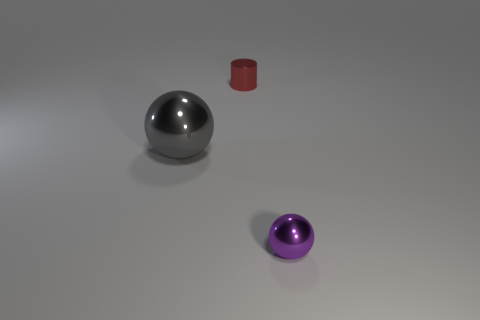What number of purple metal objects are the same size as the red metal thing?
Your answer should be very brief. 1. Is the number of tiny shiny things less than the number of small purple balls?
Provide a short and direct response. No. What shape is the small shiny thing on the left side of the shiny sphere in front of the gray ball?
Your response must be concise. Cylinder. There is a metal thing that is the same size as the cylinder; what shape is it?
Your response must be concise. Sphere. Is there a small green object that has the same shape as the large gray metal object?
Your answer should be very brief. No. What is the material of the red cylinder?
Ensure brevity in your answer.  Metal. There is a purple thing; are there any tiny purple balls to the right of it?
Provide a succinct answer. No. There is a ball behind the purple ball; what number of purple objects are on the right side of it?
Provide a succinct answer. 1. What is the material of the purple thing that is the same size as the red cylinder?
Your answer should be compact. Metal. What number of other things are there of the same material as the tiny purple sphere
Give a very brief answer. 2. 